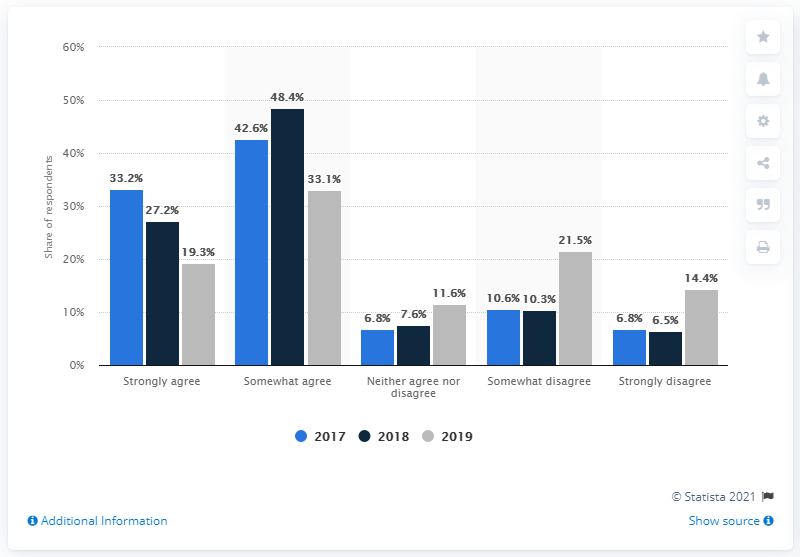Highlight a few significant elements in this photo. In 2019, a survey of Lyft drivers found that 33.1% were satisfied with the company. 